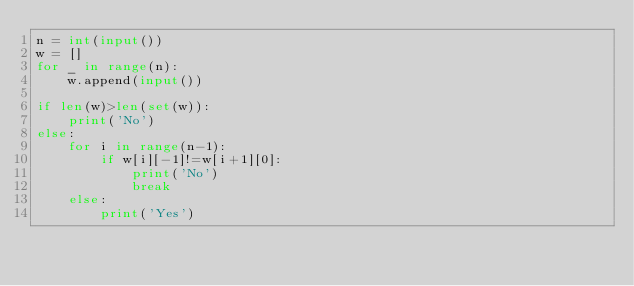Convert code to text. <code><loc_0><loc_0><loc_500><loc_500><_Python_>n = int(input())
w = []
for _ in range(n):
    w.append(input())

if len(w)>len(set(w)):
    print('No')
else:
    for i in range(n-1):
        if w[i][-1]!=w[i+1][0]:
            print('No')
            break
    else:
        print('Yes')</code> 